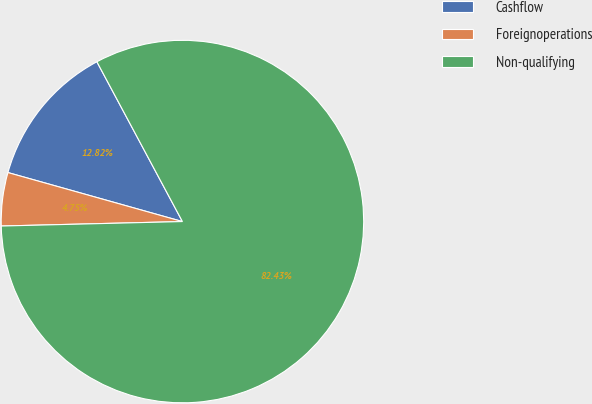Convert chart to OTSL. <chart><loc_0><loc_0><loc_500><loc_500><pie_chart><fcel>Cashflow<fcel>Foreignoperations<fcel>Non-qualifying<nl><fcel>12.82%<fcel>4.75%<fcel>82.43%<nl></chart> 